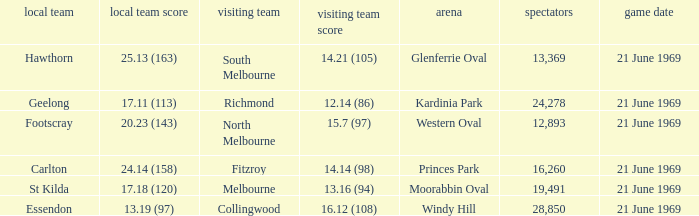When was there a game at Kardinia Park? 21 June 1969. 